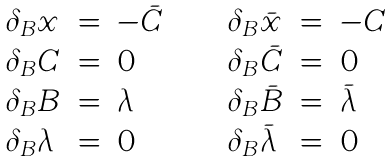Convert formula to latex. <formula><loc_0><loc_0><loc_500><loc_500>\begin{array} { l c l c l c l } \delta _ { B } x & = & - \bar { C } & \quad & \delta _ { B } \bar { x } & = & - C \\ \delta _ { B } C & = & 0 & \quad & \delta _ { B } \bar { C } & = & 0 \\ \delta _ { B } B & = & \lambda & \quad & \delta _ { B } \bar { B } & = & \bar { \lambda } \\ \delta _ { B } \lambda & = & 0 & \quad & \delta _ { B } \bar { \lambda } & = & 0 \end{array}</formula> 